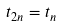Convert formula to latex. <formula><loc_0><loc_0><loc_500><loc_500>t _ { 2 n } = t _ { n }</formula> 